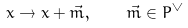<formula> <loc_0><loc_0><loc_500><loc_500>x \to x + \vec { m } , \quad \vec { m } \in P ^ { \vee }</formula> 